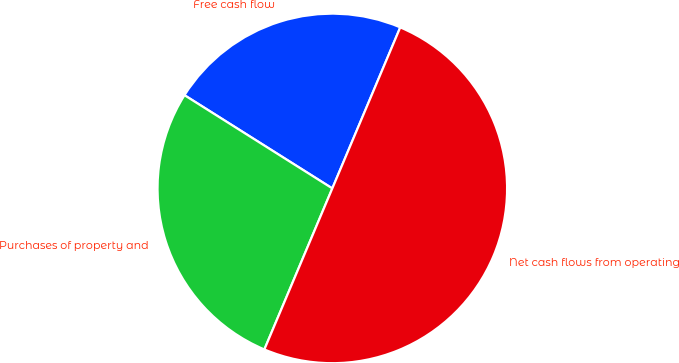Convert chart to OTSL. <chart><loc_0><loc_0><loc_500><loc_500><pie_chart><fcel>Free cash flow<fcel>Purchases of property and<fcel>Net cash flows from operating<nl><fcel>22.4%<fcel>27.6%<fcel>50.0%<nl></chart> 